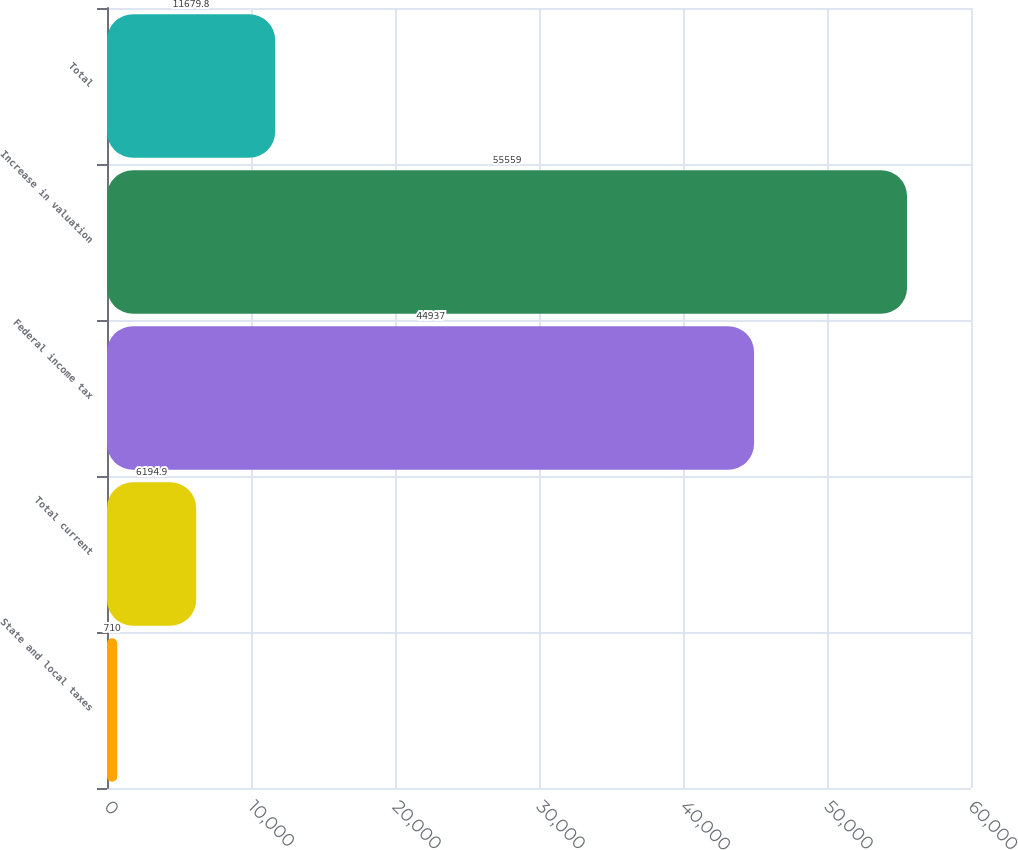Convert chart to OTSL. <chart><loc_0><loc_0><loc_500><loc_500><bar_chart><fcel>State and local taxes<fcel>Total current<fcel>Federal income tax<fcel>Increase in valuation<fcel>Total<nl><fcel>710<fcel>6194.9<fcel>44937<fcel>55559<fcel>11679.8<nl></chart> 